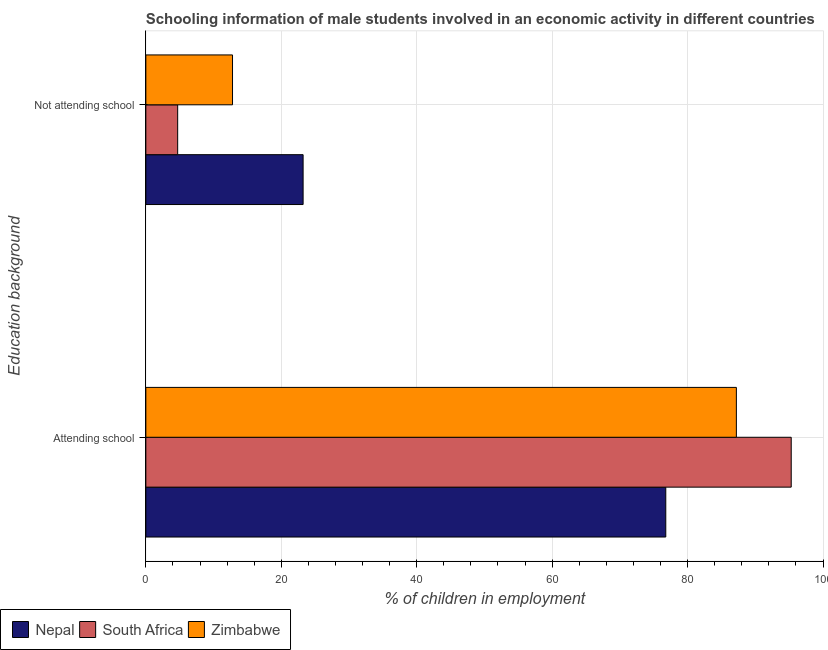How many different coloured bars are there?
Your answer should be compact. 3. How many groups of bars are there?
Provide a short and direct response. 2. How many bars are there on the 1st tick from the top?
Give a very brief answer. 3. How many bars are there on the 1st tick from the bottom?
Offer a very short reply. 3. What is the label of the 1st group of bars from the top?
Your answer should be compact. Not attending school. What is the percentage of employed males who are attending school in South Africa?
Your answer should be compact. 95.3. Across all countries, what is the maximum percentage of employed males who are attending school?
Your answer should be very brief. 95.3. Across all countries, what is the minimum percentage of employed males who are attending school?
Your answer should be compact. 76.78. In which country was the percentage of employed males who are attending school maximum?
Your answer should be very brief. South Africa. In which country was the percentage of employed males who are attending school minimum?
Ensure brevity in your answer.  Nepal. What is the total percentage of employed males who are attending school in the graph?
Your response must be concise. 259.28. What is the difference between the percentage of employed males who are not attending school in South Africa and that in Nepal?
Your answer should be very brief. -18.52. What is the difference between the percentage of employed males who are not attending school in Zimbabwe and the percentage of employed males who are attending school in Nepal?
Make the answer very short. -63.98. What is the average percentage of employed males who are attending school per country?
Give a very brief answer. 86.43. What is the difference between the percentage of employed males who are attending school and percentage of employed males who are not attending school in South Africa?
Make the answer very short. 90.6. What is the ratio of the percentage of employed males who are attending school in Nepal to that in South Africa?
Your answer should be very brief. 0.81. Is the percentage of employed males who are not attending school in Zimbabwe less than that in Nepal?
Keep it short and to the point. Yes. In how many countries, is the percentage of employed males who are attending school greater than the average percentage of employed males who are attending school taken over all countries?
Ensure brevity in your answer.  2. What does the 3rd bar from the top in Attending school represents?
Provide a succinct answer. Nepal. What does the 2nd bar from the bottom in Attending school represents?
Provide a succinct answer. South Africa. How many countries are there in the graph?
Your answer should be compact. 3. Are the values on the major ticks of X-axis written in scientific E-notation?
Your answer should be very brief. No. Does the graph contain any zero values?
Offer a terse response. No. Does the graph contain grids?
Your response must be concise. Yes. How are the legend labels stacked?
Offer a very short reply. Horizontal. What is the title of the graph?
Provide a succinct answer. Schooling information of male students involved in an economic activity in different countries. What is the label or title of the X-axis?
Offer a terse response. % of children in employment. What is the label or title of the Y-axis?
Your response must be concise. Education background. What is the % of children in employment of Nepal in Attending school?
Your answer should be very brief. 76.78. What is the % of children in employment of South Africa in Attending school?
Provide a short and direct response. 95.3. What is the % of children in employment in Zimbabwe in Attending school?
Provide a short and direct response. 87.2. What is the % of children in employment of Nepal in Not attending school?
Provide a short and direct response. 23.22. What is the % of children in employment of South Africa in Not attending school?
Provide a short and direct response. 4.7. Across all Education background, what is the maximum % of children in employment in Nepal?
Ensure brevity in your answer.  76.78. Across all Education background, what is the maximum % of children in employment of South Africa?
Provide a succinct answer. 95.3. Across all Education background, what is the maximum % of children in employment in Zimbabwe?
Provide a short and direct response. 87.2. Across all Education background, what is the minimum % of children in employment of Nepal?
Your response must be concise. 23.22. What is the total % of children in employment in South Africa in the graph?
Your answer should be very brief. 100. What is the total % of children in employment of Zimbabwe in the graph?
Give a very brief answer. 100. What is the difference between the % of children in employment in Nepal in Attending school and that in Not attending school?
Your answer should be very brief. 53.55. What is the difference between the % of children in employment in South Africa in Attending school and that in Not attending school?
Keep it short and to the point. 90.6. What is the difference between the % of children in employment of Zimbabwe in Attending school and that in Not attending school?
Give a very brief answer. 74.4. What is the difference between the % of children in employment in Nepal in Attending school and the % of children in employment in South Africa in Not attending school?
Your answer should be very brief. 72.08. What is the difference between the % of children in employment of Nepal in Attending school and the % of children in employment of Zimbabwe in Not attending school?
Make the answer very short. 63.98. What is the difference between the % of children in employment of South Africa in Attending school and the % of children in employment of Zimbabwe in Not attending school?
Ensure brevity in your answer.  82.5. What is the difference between the % of children in employment of Nepal and % of children in employment of South Africa in Attending school?
Offer a terse response. -18.52. What is the difference between the % of children in employment of Nepal and % of children in employment of Zimbabwe in Attending school?
Make the answer very short. -10.42. What is the difference between the % of children in employment in Nepal and % of children in employment in South Africa in Not attending school?
Offer a very short reply. 18.52. What is the difference between the % of children in employment of Nepal and % of children in employment of Zimbabwe in Not attending school?
Make the answer very short. 10.42. What is the ratio of the % of children in employment in Nepal in Attending school to that in Not attending school?
Offer a very short reply. 3.31. What is the ratio of the % of children in employment in South Africa in Attending school to that in Not attending school?
Your answer should be compact. 20.28. What is the ratio of the % of children in employment of Zimbabwe in Attending school to that in Not attending school?
Offer a very short reply. 6.81. What is the difference between the highest and the second highest % of children in employment of Nepal?
Offer a very short reply. 53.55. What is the difference between the highest and the second highest % of children in employment of South Africa?
Your answer should be very brief. 90.6. What is the difference between the highest and the second highest % of children in employment in Zimbabwe?
Keep it short and to the point. 74.4. What is the difference between the highest and the lowest % of children in employment of Nepal?
Your answer should be very brief. 53.55. What is the difference between the highest and the lowest % of children in employment in South Africa?
Your answer should be very brief. 90.6. What is the difference between the highest and the lowest % of children in employment of Zimbabwe?
Your response must be concise. 74.4. 